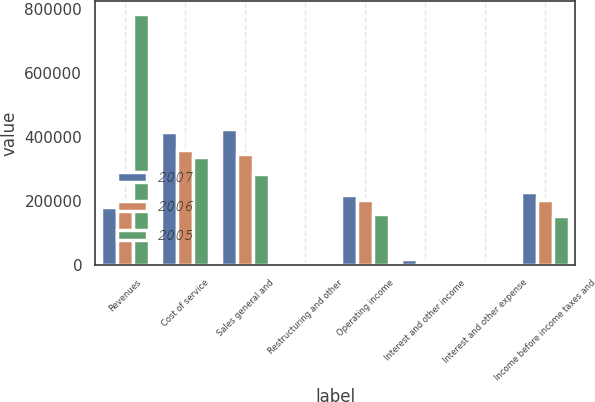Convert chart. <chart><loc_0><loc_0><loc_500><loc_500><stacked_bar_chart><ecel><fcel>Revenues<fcel>Cost of service<fcel>Sales general and<fcel>Restructuring and other<fcel>Operating income<fcel>Interest and other income<fcel>Interest and other expense<fcel>Income before income taxes and<nl><fcel>2007<fcel>180594<fcel>414837<fcel>425509<fcel>3088<fcel>218089<fcel>16706<fcel>8464<fcel>226331<nl><fcel>2006<fcel>180594<fcel>358020<fcel>347070<fcel>1878<fcel>201088<fcel>7576<fcel>7144<fcel>201520<nl><fcel>2005<fcel>784331<fcel>337272<fcel>283232<fcel>3726<fcel>160101<fcel>2194<fcel>8378<fcel>153917<nl></chart> 